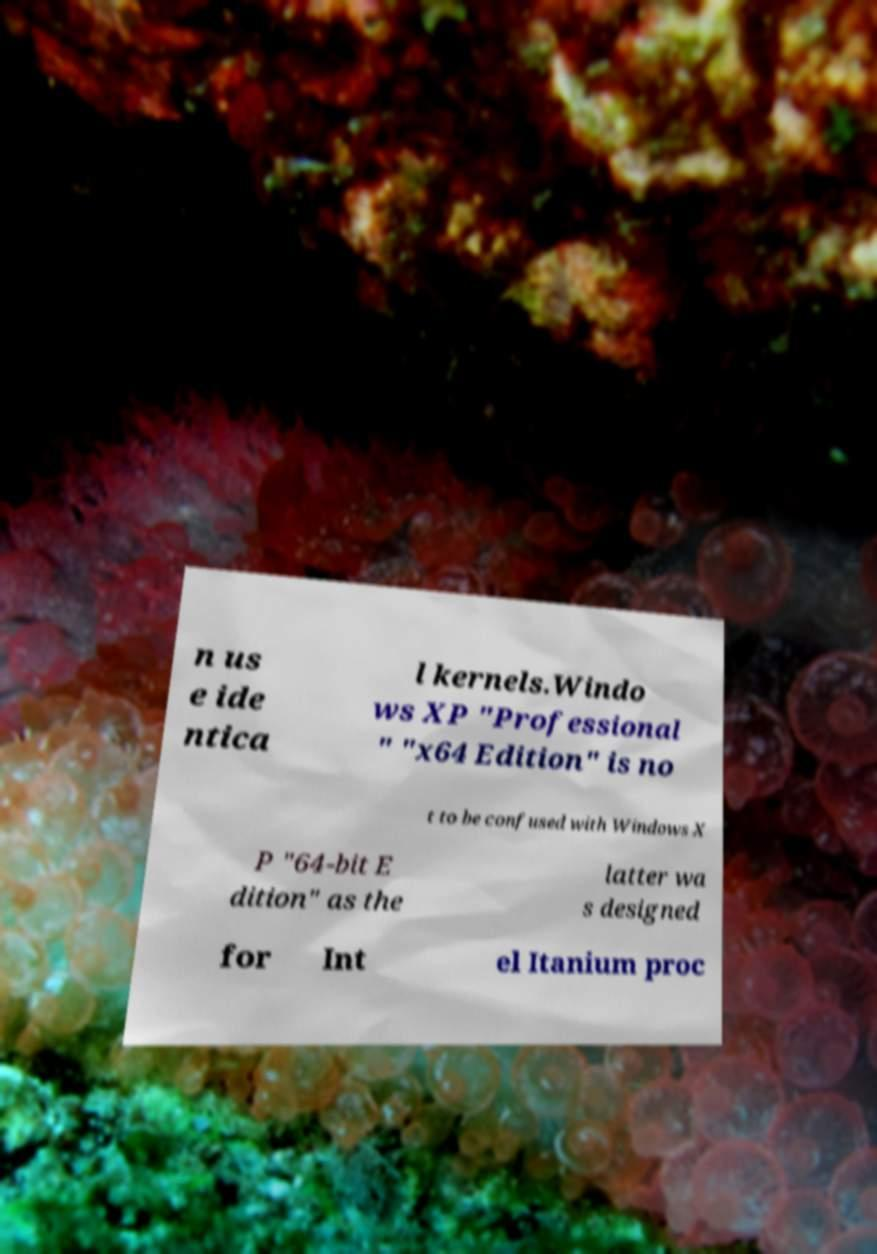There's text embedded in this image that I need extracted. Can you transcribe it verbatim? n us e ide ntica l kernels.Windo ws XP "Professional " "x64 Edition" is no t to be confused with Windows X P "64-bit E dition" as the latter wa s designed for Int el Itanium proc 